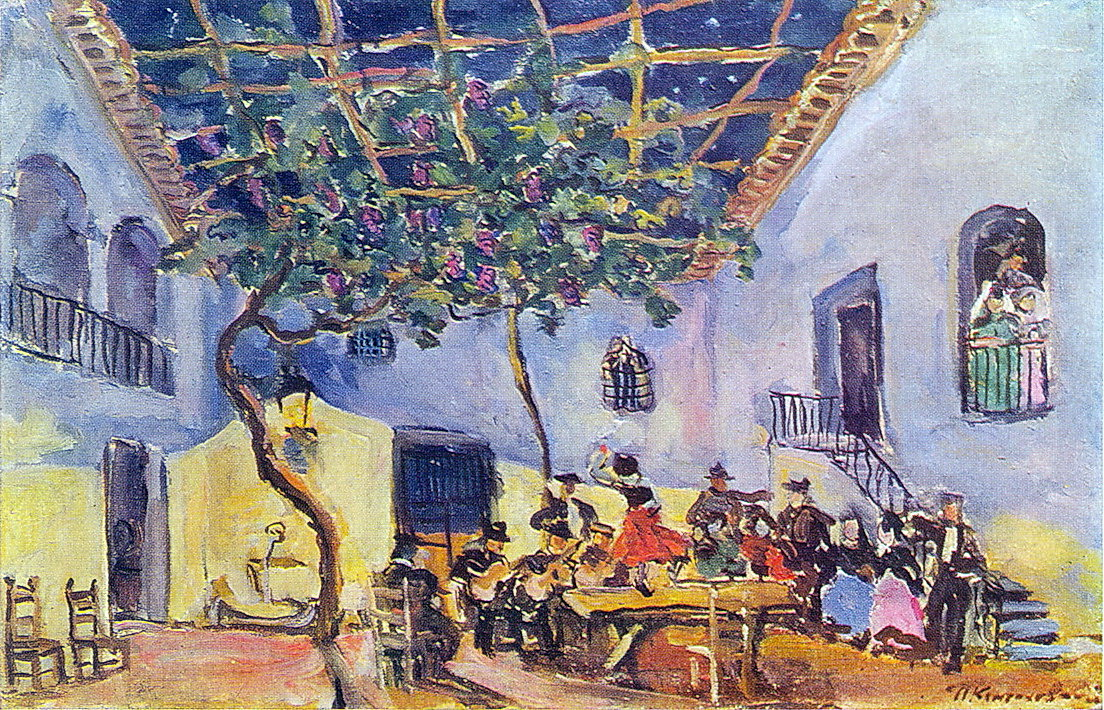Can you describe the overall atmosphere in the painting? The atmosphere in the painting is vibrant and alive, exuding a sense of joy and celebration. The bright and bold colors combined with the impressionist brushstrokes create an energetic and dynamic scene. The central courtyard, surrounded by lush greenery under a clear sky, is filled with people in colorful clothing, engaged in animated conversation. The abundance of colors and the fluidity of the brushstrokes give a sense of movement, making the scene feel lively and festive. 